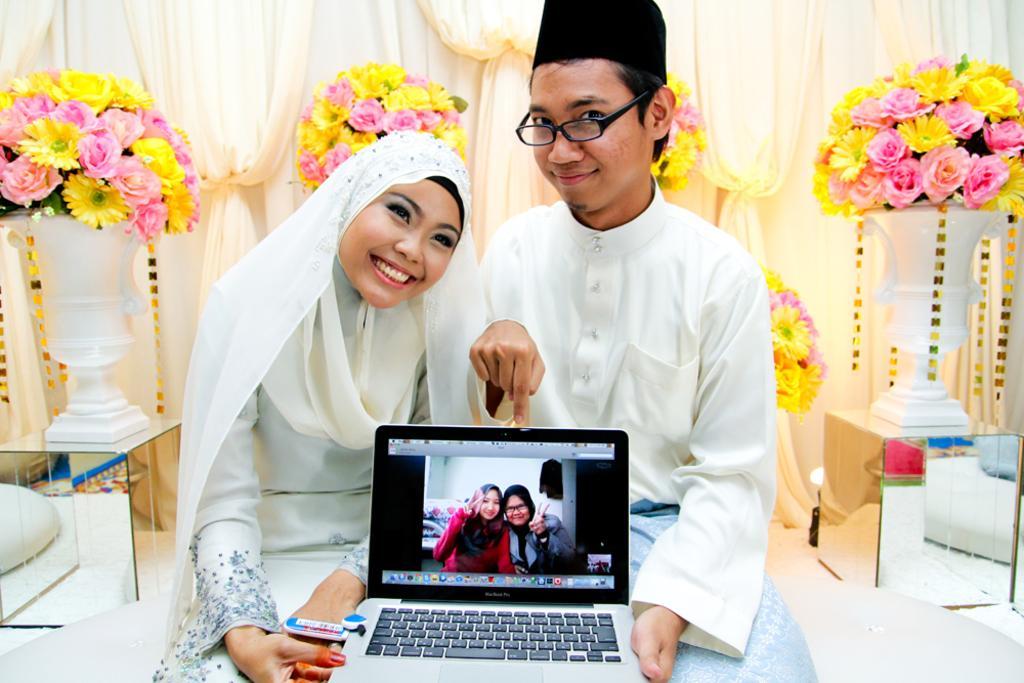How would you summarize this image in a sentence or two? In the foreground of the image there are two people wearing white color dress and holding a laptop. In the background of the image there are flower vase, curtains and decorative items. 